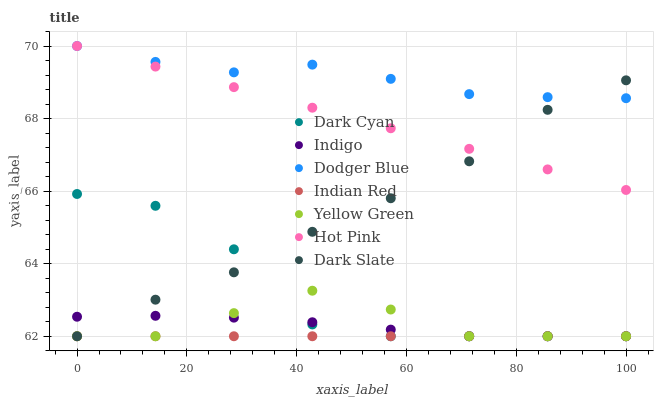Does Indian Red have the minimum area under the curve?
Answer yes or no. Yes. Does Dodger Blue have the maximum area under the curve?
Answer yes or no. Yes. Does Yellow Green have the minimum area under the curve?
Answer yes or no. No. Does Yellow Green have the maximum area under the curve?
Answer yes or no. No. Is Indian Red the smoothest?
Answer yes or no. Yes. Is Dark Cyan the roughest?
Answer yes or no. Yes. Is Yellow Green the smoothest?
Answer yes or no. No. Is Yellow Green the roughest?
Answer yes or no. No. Does Indigo have the lowest value?
Answer yes or no. Yes. Does Hot Pink have the lowest value?
Answer yes or no. No. Does Dodger Blue have the highest value?
Answer yes or no. Yes. Does Yellow Green have the highest value?
Answer yes or no. No. Is Indigo less than Hot Pink?
Answer yes or no. Yes. Is Hot Pink greater than Dark Cyan?
Answer yes or no. Yes. Does Yellow Green intersect Dark Slate?
Answer yes or no. Yes. Is Yellow Green less than Dark Slate?
Answer yes or no. No. Is Yellow Green greater than Dark Slate?
Answer yes or no. No. Does Indigo intersect Hot Pink?
Answer yes or no. No. 